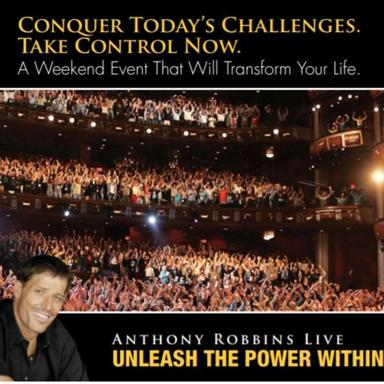What is the name of the event mentioned in the image? The event shown in the image is titled 'Unleash the Power Within,' which is a transformative weekend program hosted by Anthony Robbins. It aims to inspire and empower attendees in a high-energy environment. 